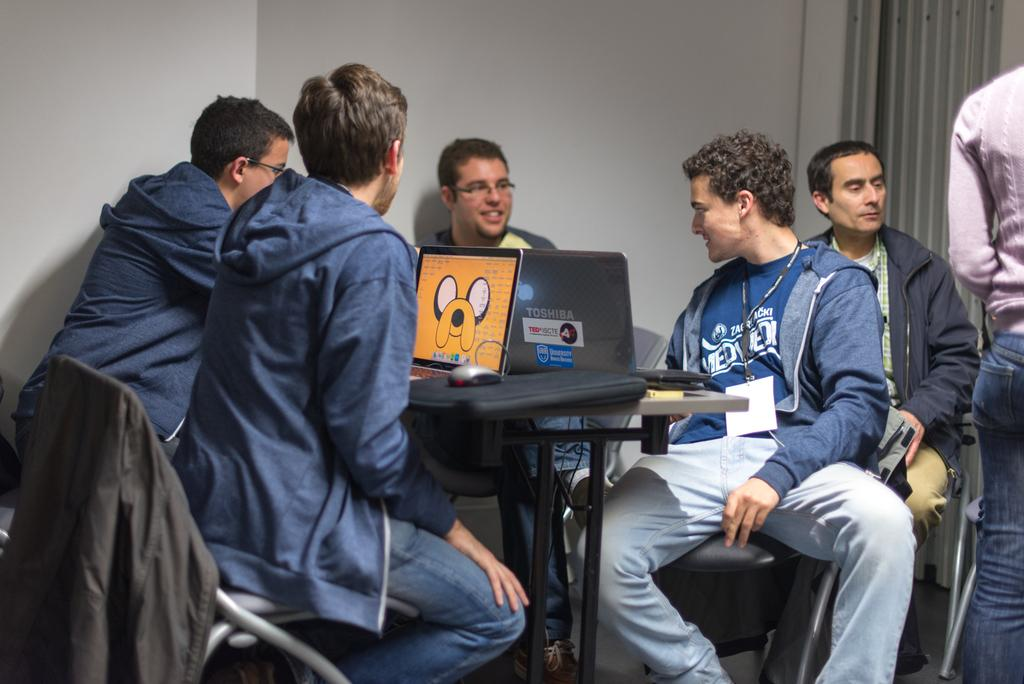How many people are in the image? There is a group of people in the image. What are some of the people in the image doing? Some people are sitting on chairs. What electronic devices are on the table in the image? There are laptops on the table. What small devices are on the table in the image? There are mice on the table. What other items can be seen on the table in the image? There are other things on the table. Can you see a yoke in the image? There is no yoke present in the image. Who is wearing the crown in the image? There is no crown or person wearing a crown in the image. 